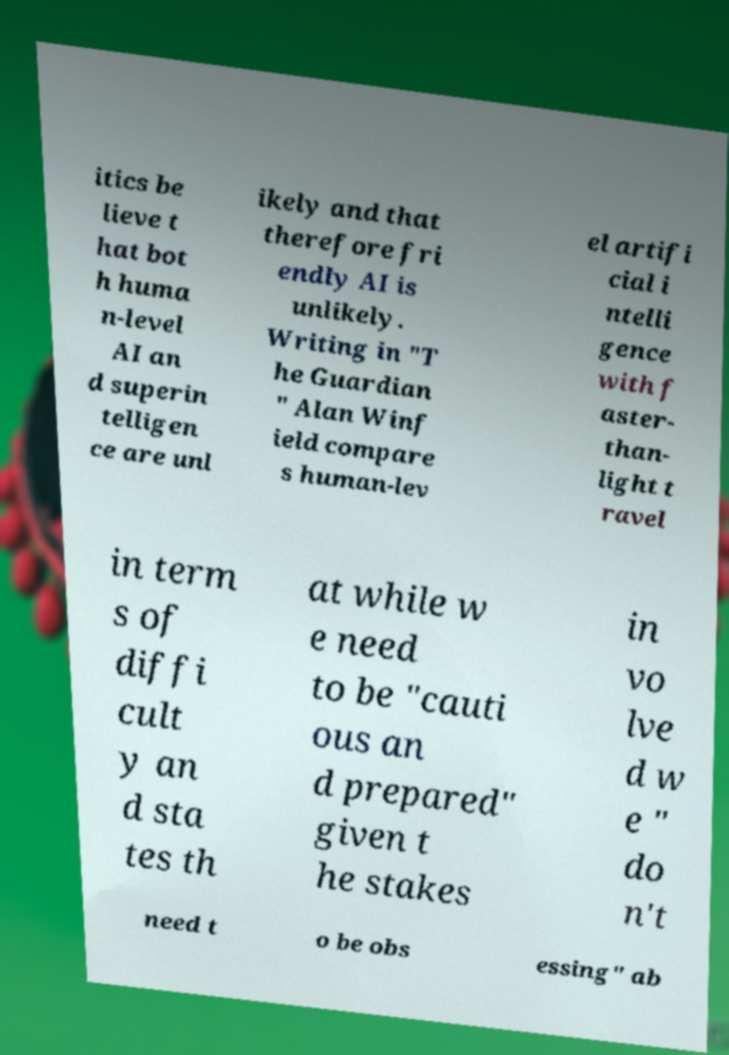There's text embedded in this image that I need extracted. Can you transcribe it verbatim? itics be lieve t hat bot h huma n-level AI an d superin telligen ce are unl ikely and that therefore fri endly AI is unlikely. Writing in "T he Guardian " Alan Winf ield compare s human-lev el artifi cial i ntelli gence with f aster- than- light t ravel in term s of diffi cult y an d sta tes th at while w e need to be "cauti ous an d prepared" given t he stakes in vo lve d w e " do n't need t o be obs essing" ab 